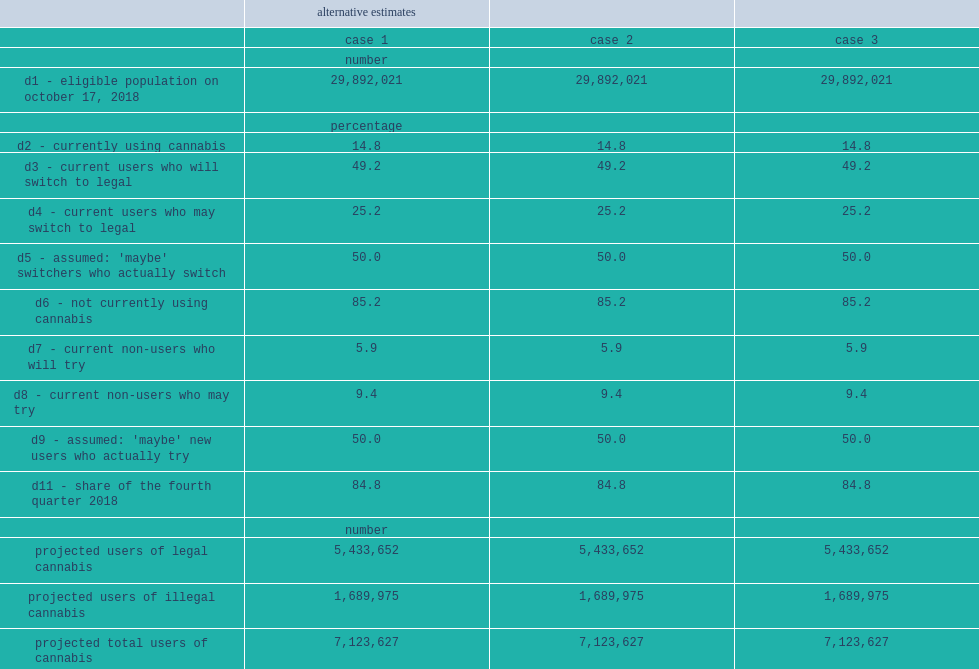What was the range of estimated fourth quarter legal demand? 816.0 1018.0. What was the range of annualized projected legal spending? 3849.0 4801.0. What was the range of projected illegal spending? 254.0 317.0. What was the range of total projected spending? 1069.0 1335.0. 